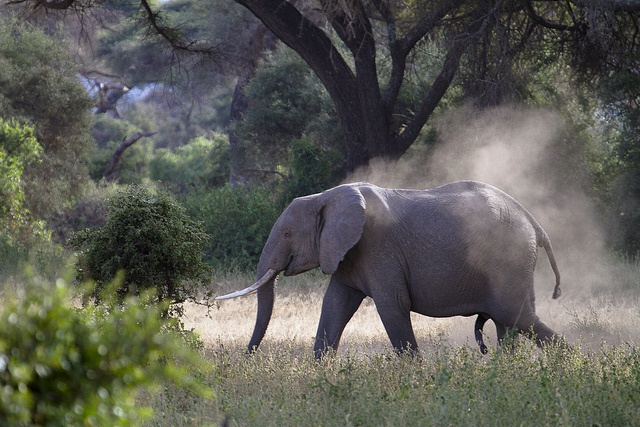Describe the objects in this image and their specific colors. I can see a elephant in gray, black, and darkgray tones in this image. 